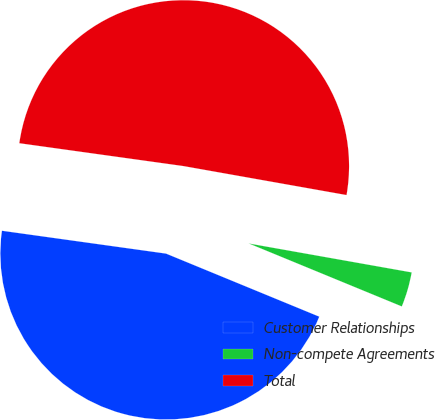Convert chart to OTSL. <chart><loc_0><loc_0><loc_500><loc_500><pie_chart><fcel>Customer Relationships<fcel>Non-compete Agreements<fcel>Total<nl><fcel>45.99%<fcel>3.41%<fcel>50.59%<nl></chart> 